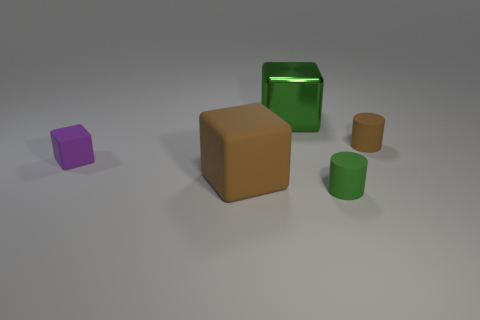Subtract all green metal blocks. How many blocks are left? 2 Add 3 matte things. How many objects exist? 8 Subtract all cylinders. How many objects are left? 3 Subtract 2 cubes. How many cubes are left? 1 Subtract all big brown cubes. Subtract all tiny green matte things. How many objects are left? 3 Add 3 tiny cylinders. How many tiny cylinders are left? 5 Add 2 tiny rubber blocks. How many tiny rubber blocks exist? 3 Subtract 1 brown blocks. How many objects are left? 4 Subtract all cyan cylinders. Subtract all purple cubes. How many cylinders are left? 2 